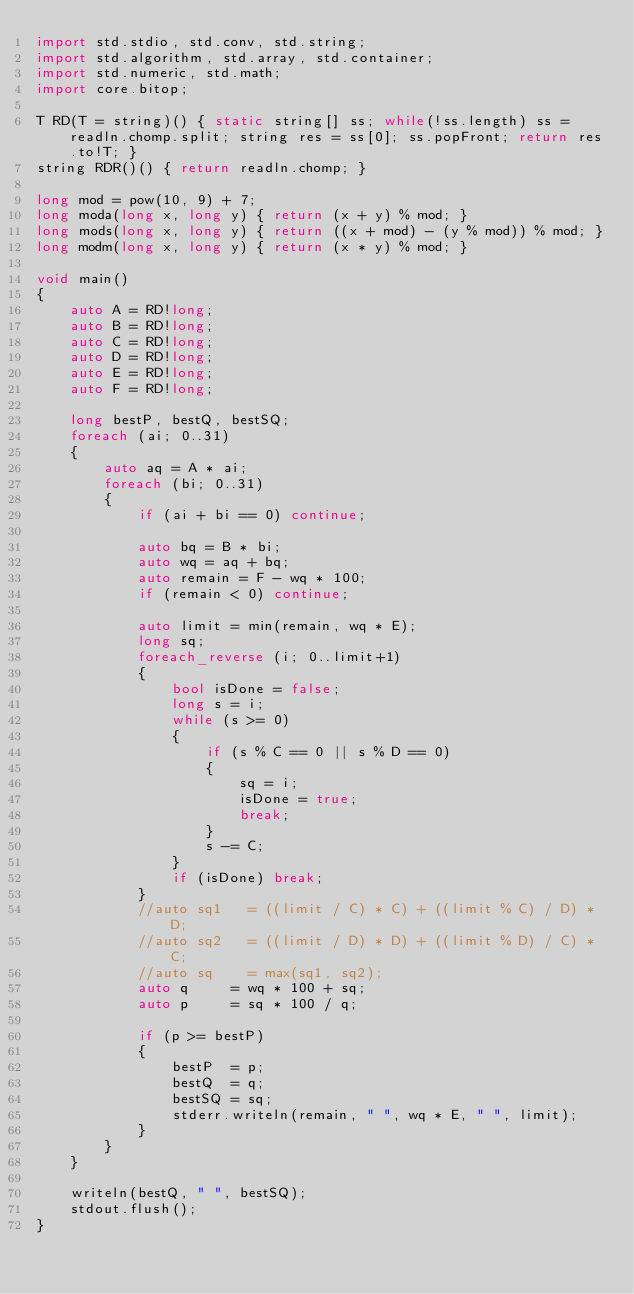<code> <loc_0><loc_0><loc_500><loc_500><_D_>import std.stdio, std.conv, std.string;
import std.algorithm, std.array, std.container;
import std.numeric, std.math;
import core.bitop;

T RD(T = string)() { static string[] ss; while(!ss.length) ss = readln.chomp.split; string res = ss[0]; ss.popFront; return res.to!T; }
string RDR()() { return readln.chomp; }

long mod = pow(10, 9) + 7;
long moda(long x, long y) { return (x + y) % mod; }
long mods(long x, long y) { return ((x + mod) - (y % mod)) % mod; }
long modm(long x, long y) { return (x * y) % mod; }

void main()
{
	auto A = RD!long;
	auto B = RD!long;
	auto C = RD!long;
	auto D = RD!long;
	auto E = RD!long;
	auto F = RD!long;

	long bestP, bestQ, bestSQ;
	foreach (ai; 0..31)
	{
		auto aq = A * ai;
		foreach (bi; 0..31)
		{
			if (ai + bi == 0) continue;

			auto bq = B * bi;
			auto wq = aq + bq;
			auto remain = F - wq * 100;
			if (remain < 0) continue;

			auto limit = min(remain, wq * E);
			long sq;
			foreach_reverse (i; 0..limit+1)
			{
				bool isDone = false;
				long s = i;
				while (s >= 0)
				{
					if (s % C == 0 || s % D == 0)
					{
						sq = i;
						isDone = true;
						break;
					}
					s -= C;
				}
				if (isDone) break;
			}
			//auto sq1   = ((limit / C) * C) + ((limit % C) / D) * D;
			//auto sq2   = ((limit / D) * D) + ((limit % D) / C) * C;
			//auto sq    = max(sq1, sq2);
			auto q     = wq * 100 + sq;
			auto p     = sq * 100 / q;

			if (p >= bestP)
			{
				bestP  = p;
				bestQ  = q;
				bestSQ = sq;
				stderr.writeln(remain, " ", wq * E, " ", limit);
			}
		}
	}
	
	writeln(bestQ, " ", bestSQ);
	stdout.flush();
}</code> 